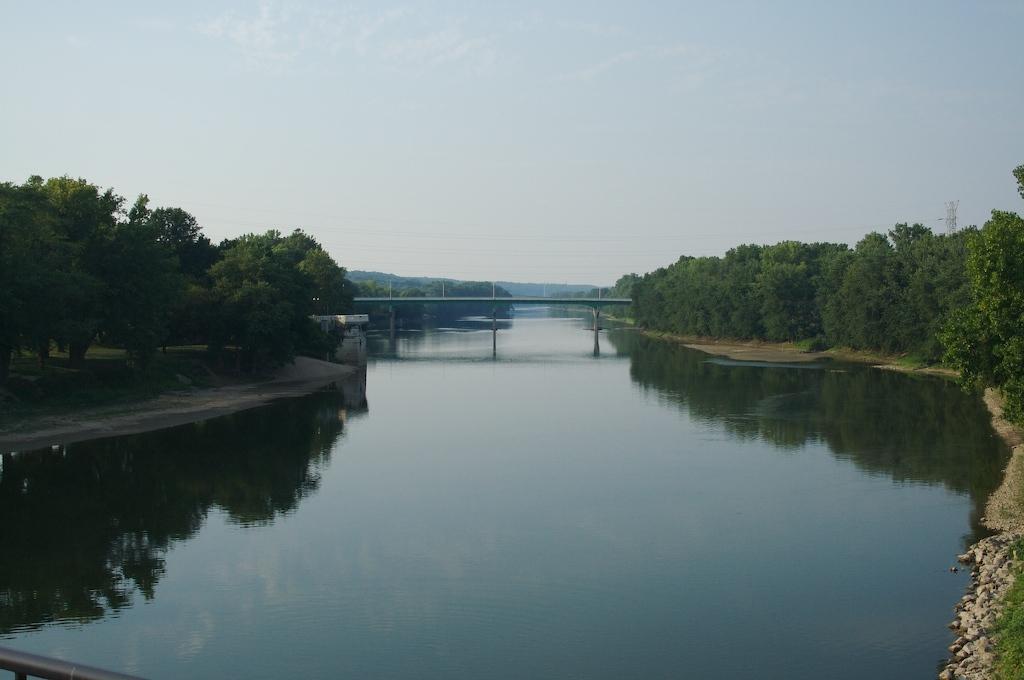Can you describe this image briefly? In this picture we can see a bridge, under this bridge we can see water, here we can see a shed, trees and in the background we can see poles, mountains, sky. 